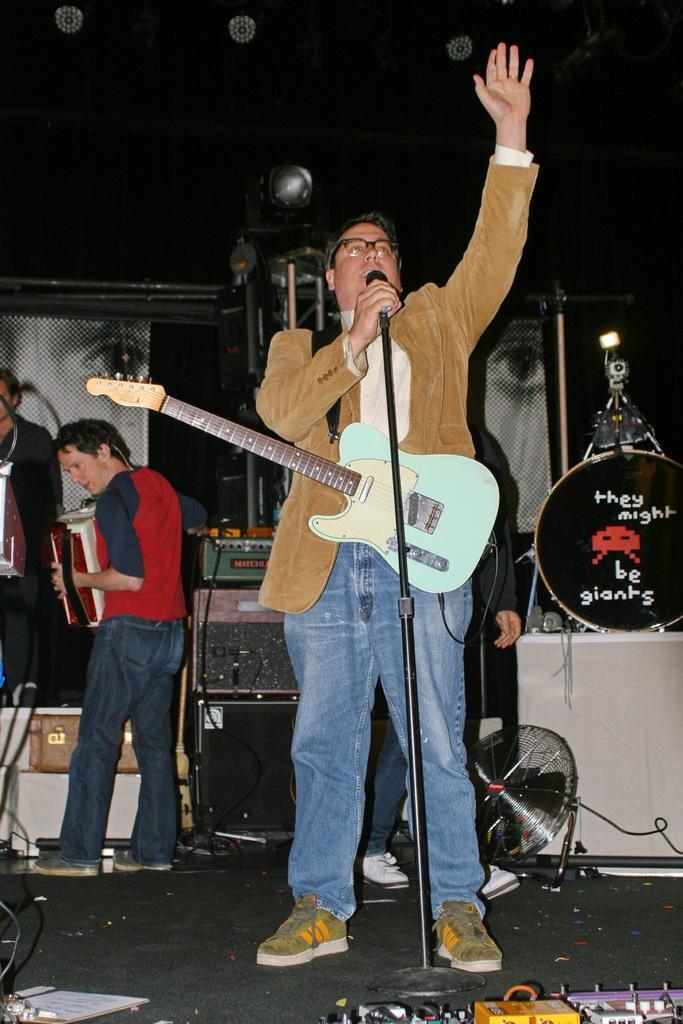Could you give a brief overview of what you see in this image? This image consist of three men. It is clicked in a concert. In the front, the man is wearing brown jacket and singing in a mic. To the left, the two men are playing musical instruments. To the right, there is a band setup. At the top there are lights. 